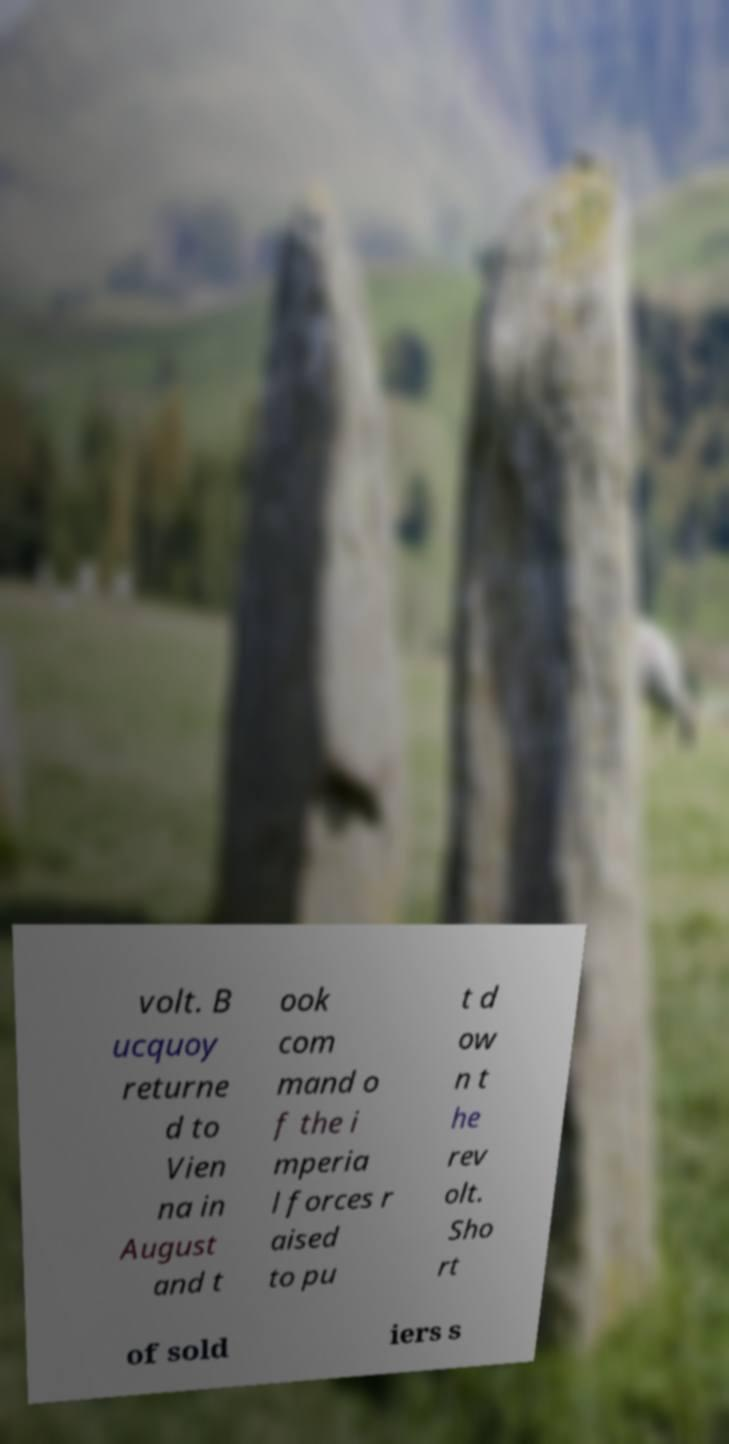Can you read and provide the text displayed in the image?This photo seems to have some interesting text. Can you extract and type it out for me? volt. B ucquoy returne d to Vien na in August and t ook com mand o f the i mperia l forces r aised to pu t d ow n t he rev olt. Sho rt of sold iers s 